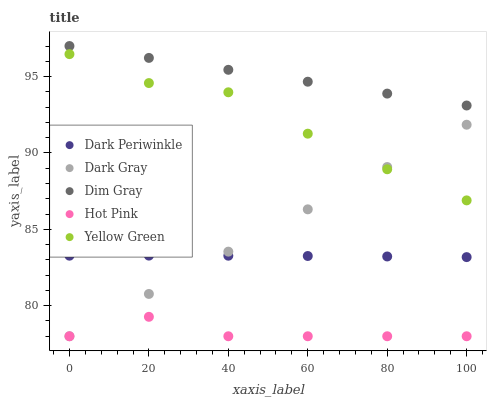Does Hot Pink have the minimum area under the curve?
Answer yes or no. Yes. Does Dim Gray have the maximum area under the curve?
Answer yes or no. Yes. Does Yellow Green have the minimum area under the curve?
Answer yes or no. No. Does Yellow Green have the maximum area under the curve?
Answer yes or no. No. Is Dark Gray the smoothest?
Answer yes or no. Yes. Is Yellow Green the roughest?
Answer yes or no. Yes. Is Dim Gray the smoothest?
Answer yes or no. No. Is Dim Gray the roughest?
Answer yes or no. No. Does Dark Gray have the lowest value?
Answer yes or no. Yes. Does Yellow Green have the lowest value?
Answer yes or no. No. Does Dim Gray have the highest value?
Answer yes or no. Yes. Does Yellow Green have the highest value?
Answer yes or no. No. Is Hot Pink less than Dark Periwinkle?
Answer yes or no. Yes. Is Dim Gray greater than Dark Gray?
Answer yes or no. Yes. Does Yellow Green intersect Dark Gray?
Answer yes or no. Yes. Is Yellow Green less than Dark Gray?
Answer yes or no. No. Is Yellow Green greater than Dark Gray?
Answer yes or no. No. Does Hot Pink intersect Dark Periwinkle?
Answer yes or no. No. 